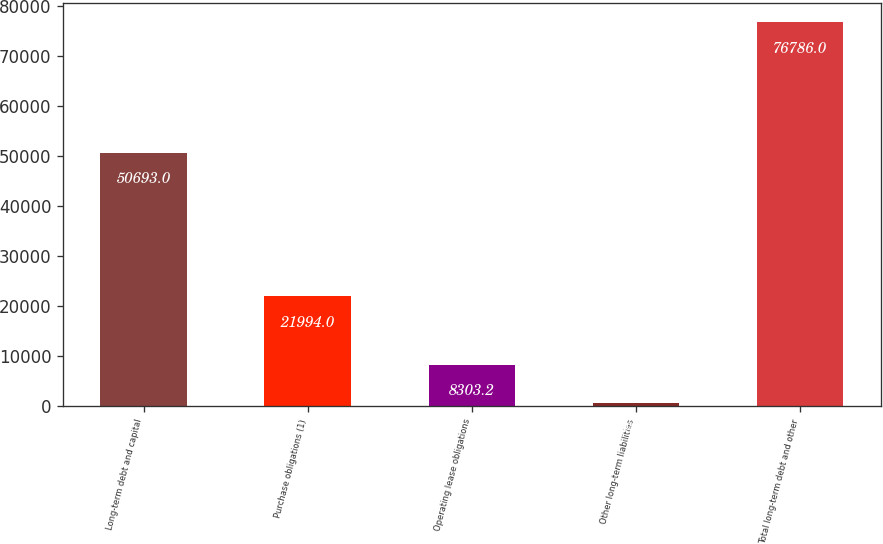Convert chart to OTSL. <chart><loc_0><loc_0><loc_500><loc_500><bar_chart><fcel>Long-term debt and capital<fcel>Purchase obligations (1)<fcel>Operating lease obligations<fcel>Other long-term liabilities<fcel>Total long-term debt and other<nl><fcel>50693<fcel>21994<fcel>8303.2<fcel>694<fcel>76786<nl></chart> 